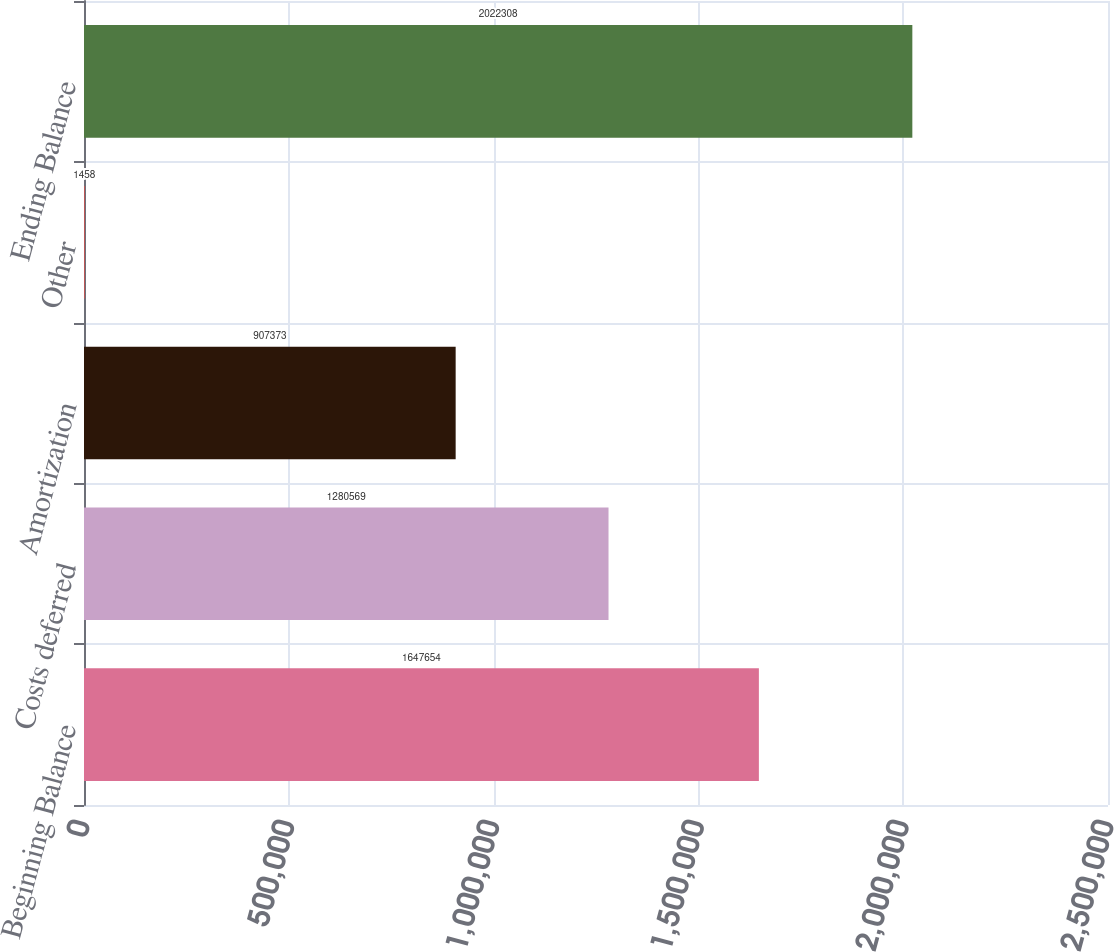Convert chart. <chart><loc_0><loc_0><loc_500><loc_500><bar_chart><fcel>Beginning Balance<fcel>Costs deferred<fcel>Amortization<fcel>Other<fcel>Ending Balance<nl><fcel>1.64765e+06<fcel>1.28057e+06<fcel>907373<fcel>1458<fcel>2.02231e+06<nl></chart> 